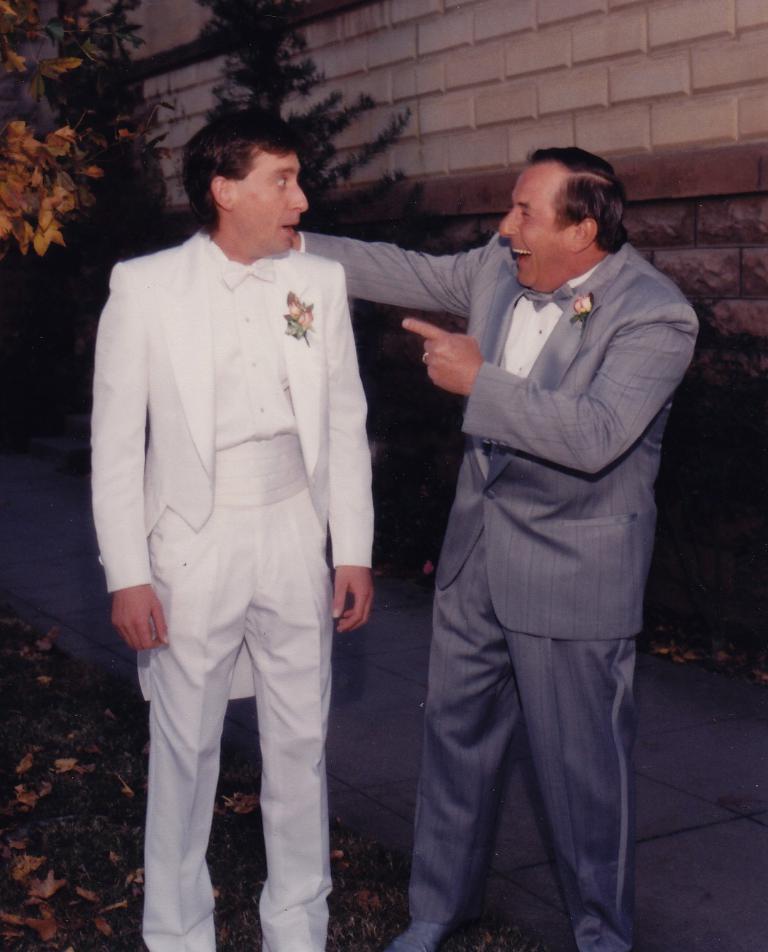Describe this image in one or two sentences. In this image we can see two men standing. In the back there is a brick wall. Also there are branches of trees. On the ground there is dried leaves. 